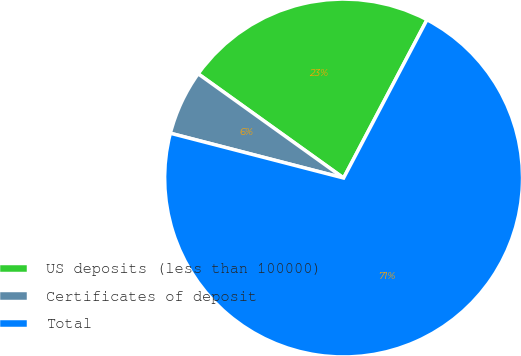Convert chart to OTSL. <chart><loc_0><loc_0><loc_500><loc_500><pie_chart><fcel>US deposits (less than 100000)<fcel>Certificates of deposit<fcel>Total<nl><fcel>22.82%<fcel>5.87%<fcel>71.3%<nl></chart> 